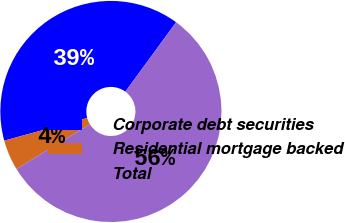Convert chart. <chart><loc_0><loc_0><loc_500><loc_500><pie_chart><fcel>Corporate debt securities<fcel>Residential mortgage backed<fcel>Total<nl><fcel>39.3%<fcel>4.46%<fcel>56.25%<nl></chart> 